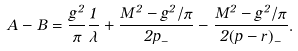Convert formula to latex. <formula><loc_0><loc_0><loc_500><loc_500>A - B = \frac { g ^ { 2 } } { \pi } \frac { 1 } { \lambda } + \frac { M ^ { 2 } - g ^ { 2 } / \pi } { 2 p _ { - } } - \frac { M ^ { 2 } - g ^ { 2 } / \pi } { 2 ( p - r ) _ { - } } .</formula> 